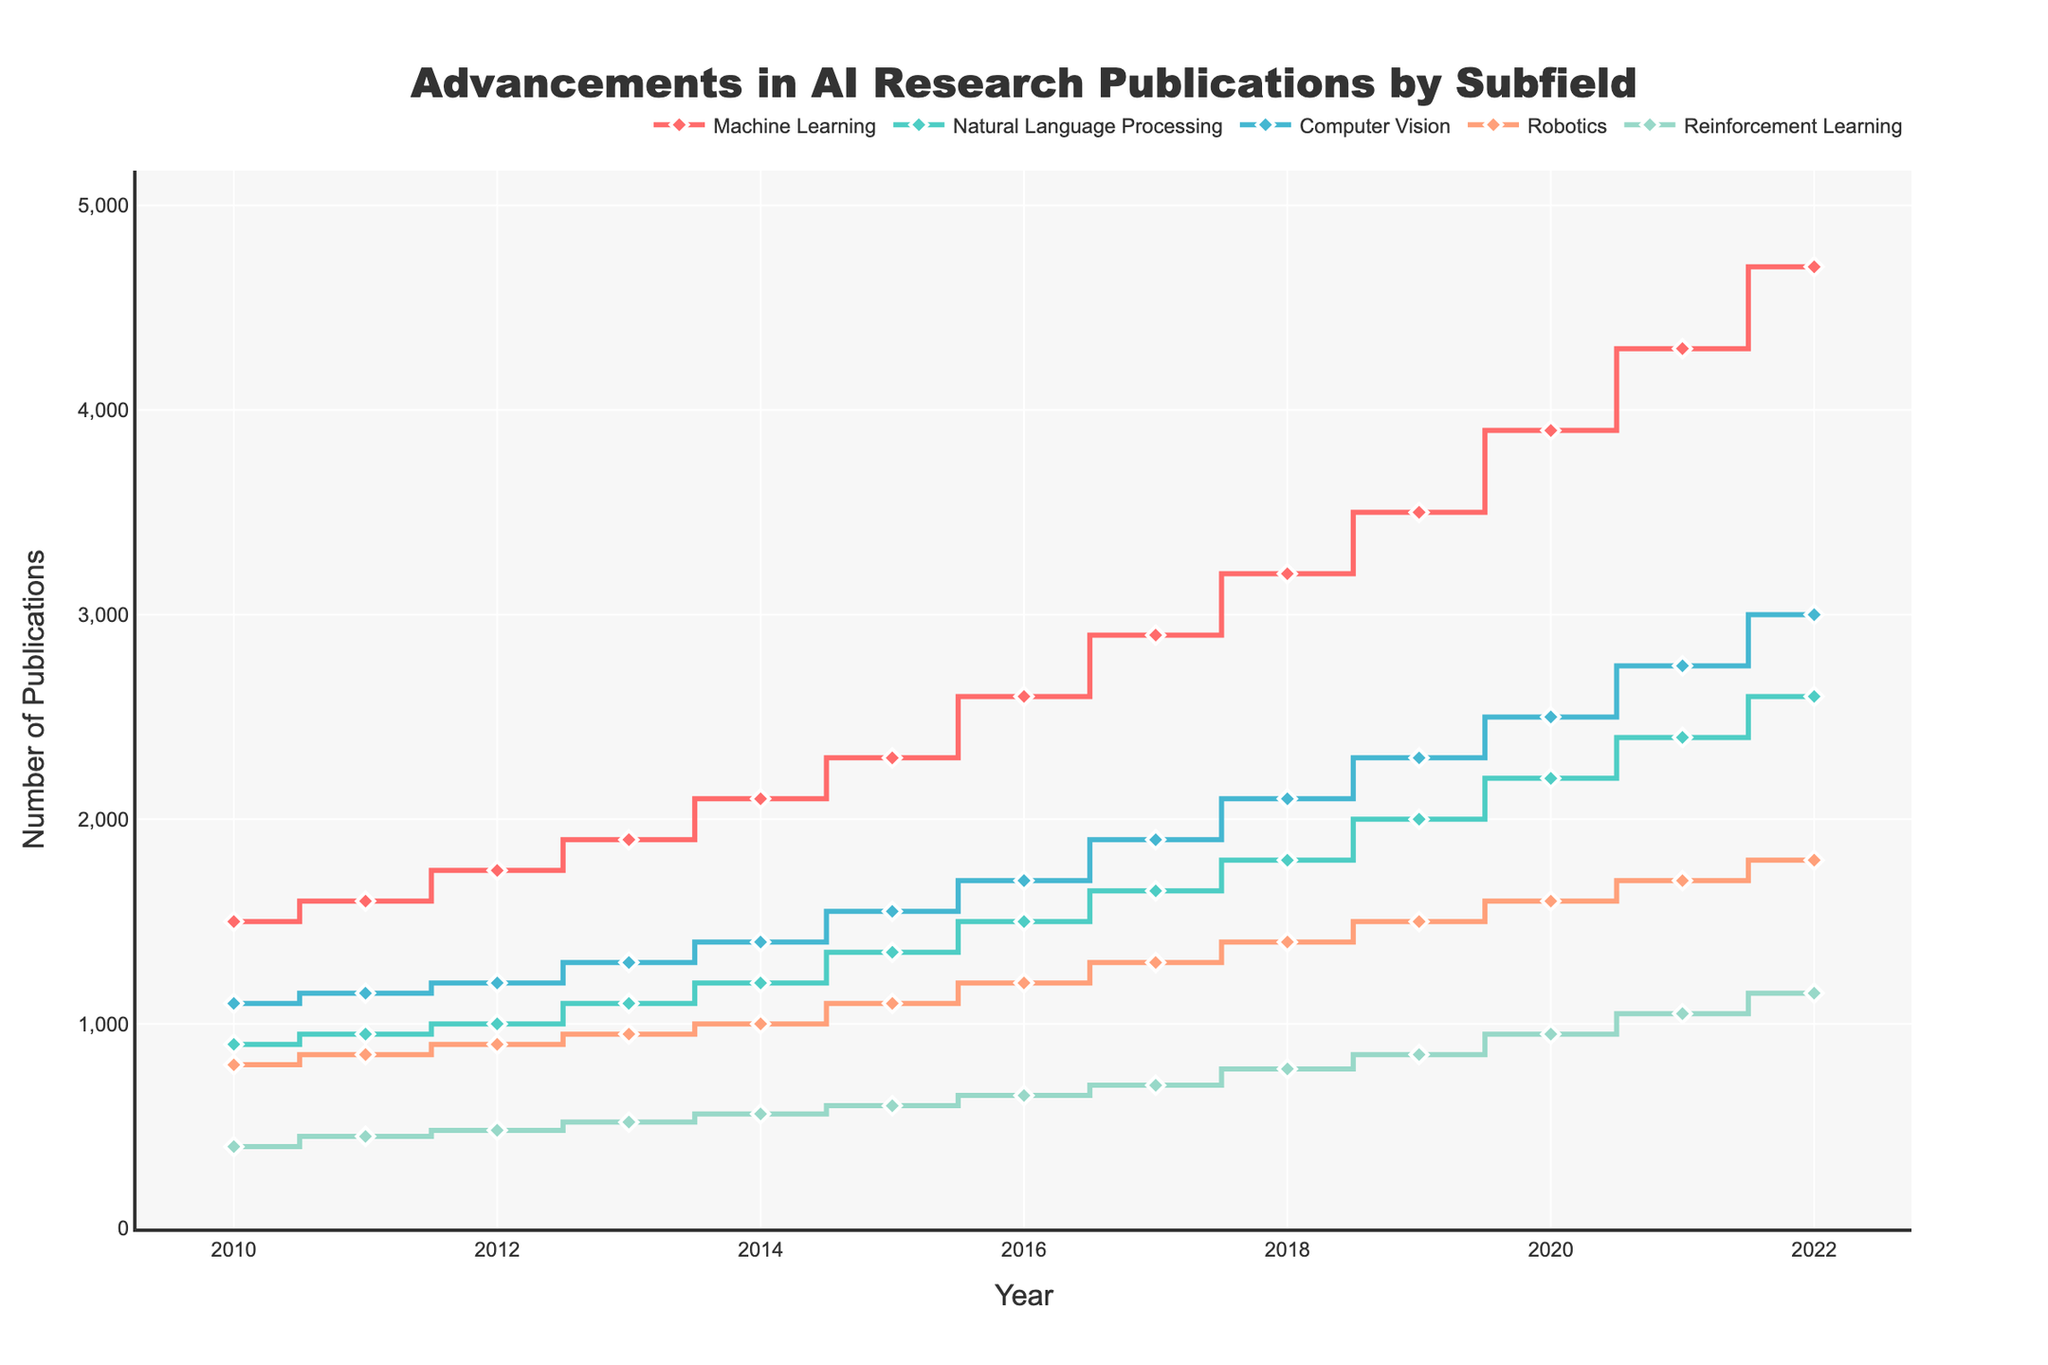Which subfield had the highest number of publications in 2022? By looking at the plot for 2022, we can see that the line with the highest endpoint represents "Machine Learning" with 4700 publications.
Answer: Machine Learning How did the number of publications in Robotics progress between 2010 and 2022? Following the line for "Robotics" from 2010 to 2022, we see a steady increase from 800 publications in 2010 to 1800 publications in 2022.
Answer: Steadily increased from 800 to 1800 Which year saw a higher number of publications in Reinforcement Learning: 2015 or 2016? Comparing the values for "Reinforcement Learning" in 2015 (600) and 2016 (650), we see that 2016 has a higher number.
Answer: 2016 What are the average number of publications for Computer Vision over the years 2010 to 2022? Sum the number of publications for Computer Vision from 2010-2022 (1100+1150+1200+1300+1400+1550+1700+1900+2100+2300+2500+2750+3000) and then divide by 13 years. The sum is 26150, so the average is 26150 / 13 = 2011.5
Answer: 2011.5 By how much did the number of publications in Natural Language Processing increase from 2010 to 2022? Subtract the number of publications in 2010 (900) from the number in 2022 (2600), resulting in an increase of 2600 - 900 = 1700 publications.
Answer: 1700 Which subfield had the least growth in publication numbers from 2010 to 2022? Calculate the difference between publication numbers in 2022 and 2010 for each subfield. Machine Learning: 4700-1500=3200, Natural Language Processing: 2600-900=1700, Computer Vision: 3000-1100=1900, Robotics: 1800-800=1000, Reinforcement Learning: 1150-400=750. Reinforcement Learning had the least growth with 750.
Answer: Reinforcement Learning Was there ever a year where the number of publications for Robotics was greater than Computer Vision? Observing the lines for Robotics and Computer Vision from 2010 to 2022, Computer Vision always has higher or equal values than Robotics, so there is no such year.
Answer: No In what year did Machine Learning publications first exceed 3000? Trace the "Machine Learning" line and find the first year where the number exceeds 3000, which happens in 2018 with 3200 publications.
Answer: 2018 What is the sum of publications for all subfields in 2015? Adding up the publications for all subfields in 2015: Machine Learning (2300), Natural Language Processing (1350), Computer Vision (1550), Robotics (1100), and Reinforcement Learning (600). The total is 2300+1350+1550+1100+600 = 6900.
Answer: 6900 